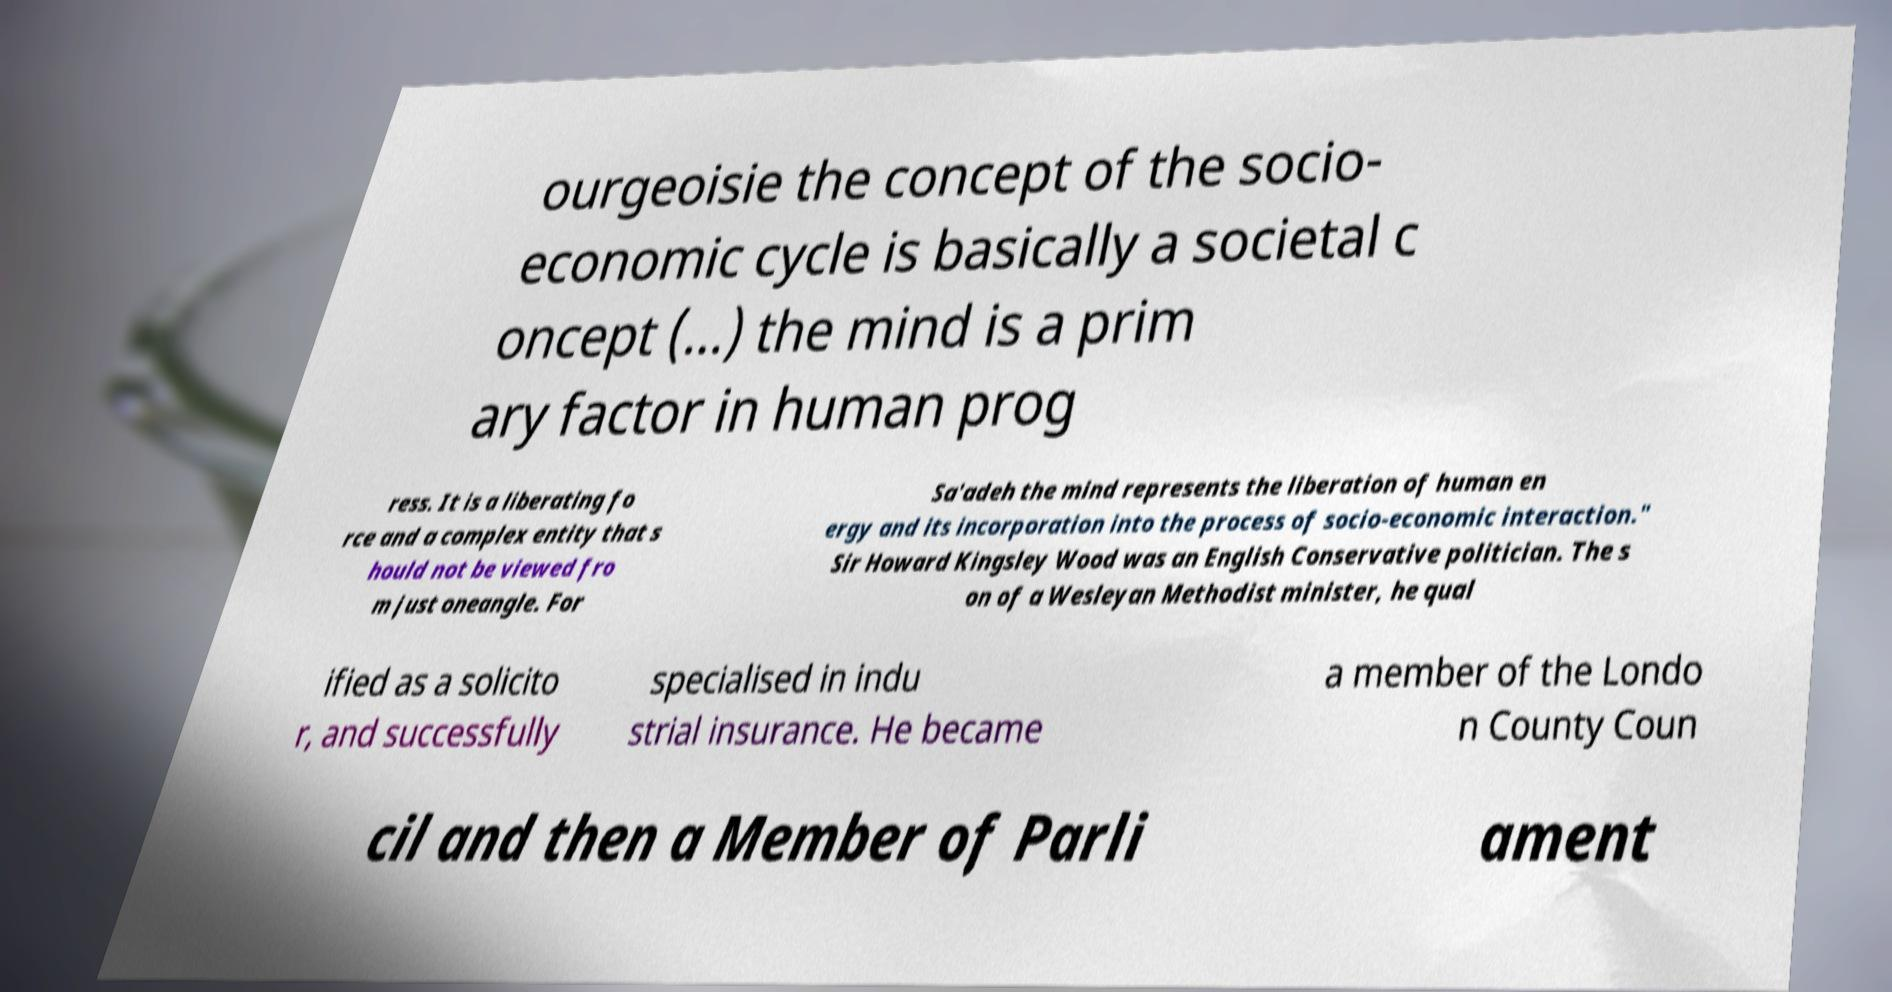For documentation purposes, I need the text within this image transcribed. Could you provide that? ourgeoisie the concept of the socio- economic cycle is basically a societal c oncept (...) the mind is a prim ary factor in human prog ress. It is a liberating fo rce and a complex entity that s hould not be viewed fro m just oneangle. For Sa'adeh the mind represents the liberation of human en ergy and its incorporation into the process of socio-economic interaction." Sir Howard Kingsley Wood was an English Conservative politician. The s on of a Wesleyan Methodist minister, he qual ified as a solicito r, and successfully specialised in indu strial insurance. He became a member of the Londo n County Coun cil and then a Member of Parli ament 